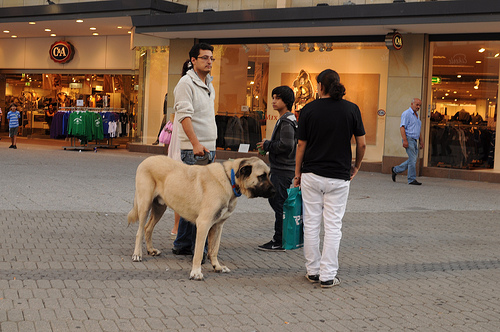Are there dogs to the right of the bag the woman is holding? No, there are no dogs to the right of the bag the woman is holding; that space is primarily occupied by people. 